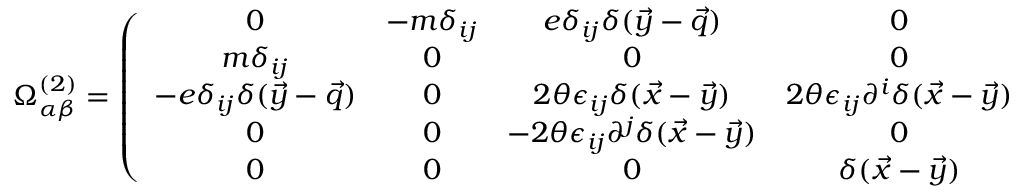Convert formula to latex. <formula><loc_0><loc_0><loc_500><loc_500>\Omega _ { \alpha \beta } ^ { ( 2 ) } = \left ( \begin{array} { c c c c c } { 0 } & { { - m \delta _ { i j } } } & { { e \delta _ { i j } \delta ( \vec { y } - \vec { q } ) } } & { 0 } & { 0 } \\ { { m \delta _ { i j } } } & { 0 } & { 0 } & { 0 } & { 0 } \\ { { - e \delta _ { i j } \delta ( \vec { y } - \vec { q } ) } } & { 0 } & { { 2 \theta \epsilon _ { i j } \delta ( \vec { x } - \vec { y } ) } } & { { 2 \theta \epsilon _ { i j } \partial ^ { i } \delta ( \vec { x } - \vec { y } ) } } & { 0 } \\ { 0 } & { 0 } & { { - 2 \theta \epsilon _ { i j } \partial ^ { j } \delta ( \vec { x } - \vec { y } ) } } & { 0 } & { { - \delta ( \vec { x } - \vec { y } ) } } \\ { 0 } & { 0 } & { 0 } & { { \delta ( \vec { x } - \vec { y } ) } } & { 0 } \end{array} \right )</formula> 